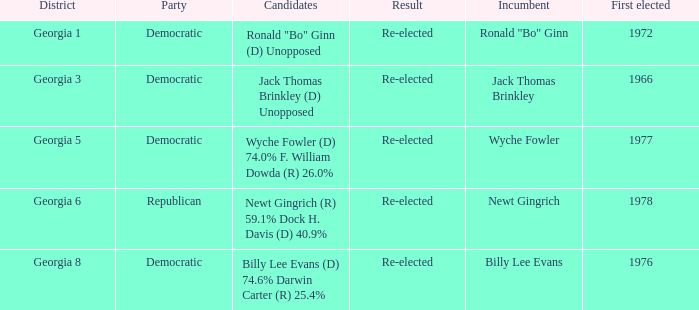How many candidates were first elected in 1972? 1.0. 